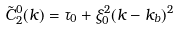<formula> <loc_0><loc_0><loc_500><loc_500>\tilde { C } ^ { 0 } _ { 2 } ( k ) = \tau _ { 0 } + \xi _ { 0 } ^ { 2 } ( k - k _ { b } ) ^ { 2 }</formula> 